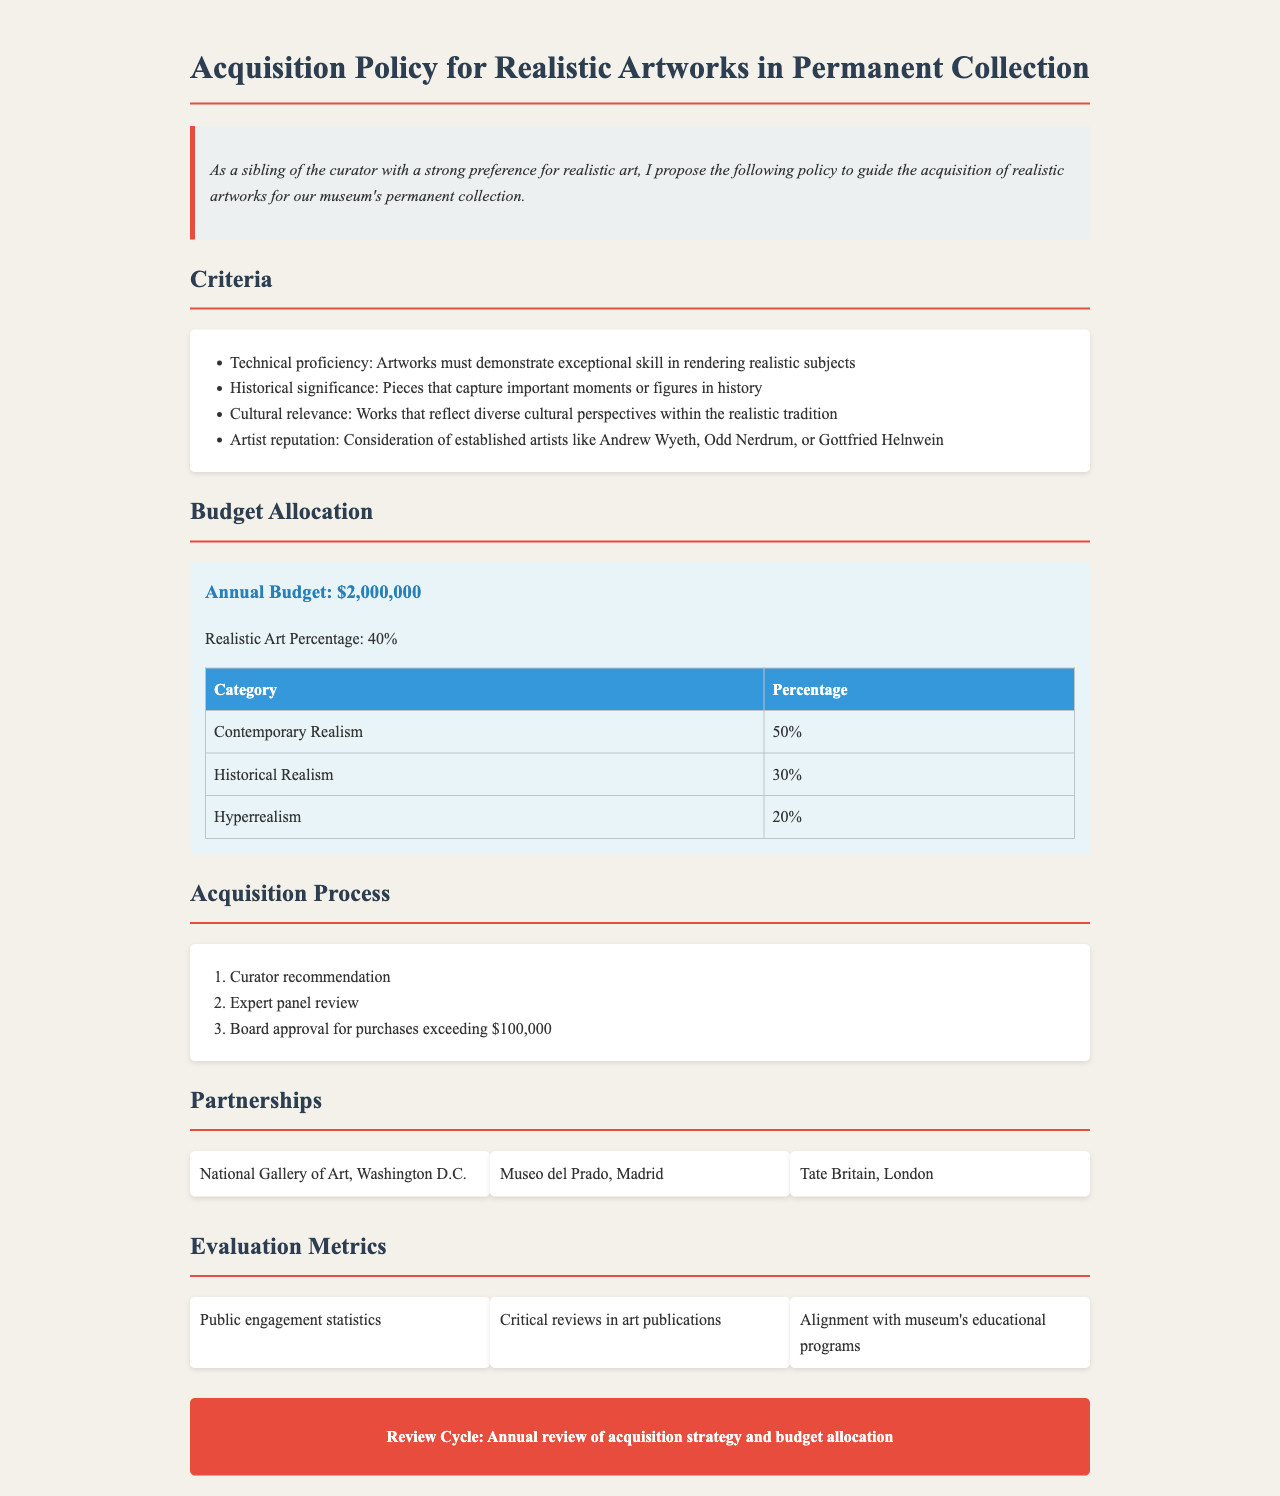What is the annual budget for acquiring realistic artworks? The document specifies the annual budget allocated for realistic artworks as $2,000,000.
Answer: $2,000,000 What percentage of the budget is allocated to realistic art? The document indicates that 40% of the annual budget is designated for realistic art.
Answer: 40% Which category receives the highest percentage allocation? The document states that Contemporary Realism receives 50% of the budget allocation, making it the highest.
Answer: Contemporary Realism Who are considered established artists for acquisition? The document lists Andrew Wyeth, Odd Nerdrum, and Gottfried Helnwein as established artists to be considered for acquisitions.
Answer: Andrew Wyeth, Odd Nerdrum, Gottfried Helnwein What is the first step in the acquisition process? The document outlines that the first step in the acquisition process is the Curator recommendation.
Answer: Curator recommendation Which evaluation metric reflects public involvement? The document mentions public engagement statistics as one of the metrics for evaluation.
Answer: Public engagement statistics What is the review cycle for the acquisition strategy? According to the document, the review cycle for the acquisition strategy is annual.
Answer: Annual How many categories are in the budget allocation? The document describes three categories in the budget allocation for realistic artworks.
Answer: Three What is the minimum purchase amount requiring board approval? The document states that purchases exceeding $100,000 require board approval.
Answer: $100,000 